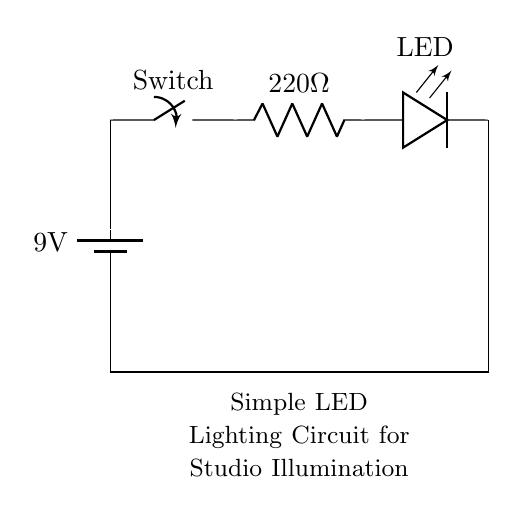What is the voltage of the battery? The battery is labeled as 9 volts in the circuit diagram, indicating the source voltage provided to the circuit.
Answer: 9 volts What is the resistance value in the circuit? The resistor in the circuit is labeled as 220 ohms, which denotes its resistance value that limits the current flowing through the circuit.
Answer: 220 ohms How many LEDs are present in this circuit? There is one LED depicted in the circuit diagram, illustrated by the LED symbol connected after the resistor.
Answer: One What is the purpose of the switch in this circuit? The switch is used to either connect or disconnect the circuit, allowing control over whether the LED lights up or not, contributing to its functionality in lighting.
Answer: Control If the LED operates at a current of 20 mA, what is the total current through the circuit? Given that the LED is designed for a current of 20 mA, the circuit is arranged such that the same amount of current flows through the entire series circuit, thus the total current is also 20 mA.
Answer: 20 mA What type of circuit configuration is used here? The circuit is configured as a series circuit, where the components are connected end-to-end, meaning the current has only one path to follow through the entire circuit.
Answer: Series What is the role of the resistor in this circuit? The resistor limits the amount of current that flows through the LED to prevent it from exceeding its maximum rated current, thereby protecting the LED from damage.
Answer: Current limiting 